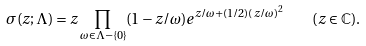<formula> <loc_0><loc_0><loc_500><loc_500>\sigma ( z ; \Lambda ) = z \prod _ { \omega \in \Lambda - \{ 0 \} } ( 1 - z / \omega ) e ^ { z / \omega + ( 1 / 2 ) ( z / \omega ) ^ { 2 } } \quad ( z \in \mathbb { C } ) .</formula> 